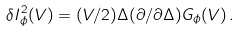<formula> <loc_0><loc_0><loc_500><loc_500>\delta I _ { \phi } ^ { 2 } ( V ) = ( V / 2 ) \Delta ( \partial / \partial \Delta ) G _ { \phi } ( V ) \, .</formula> 